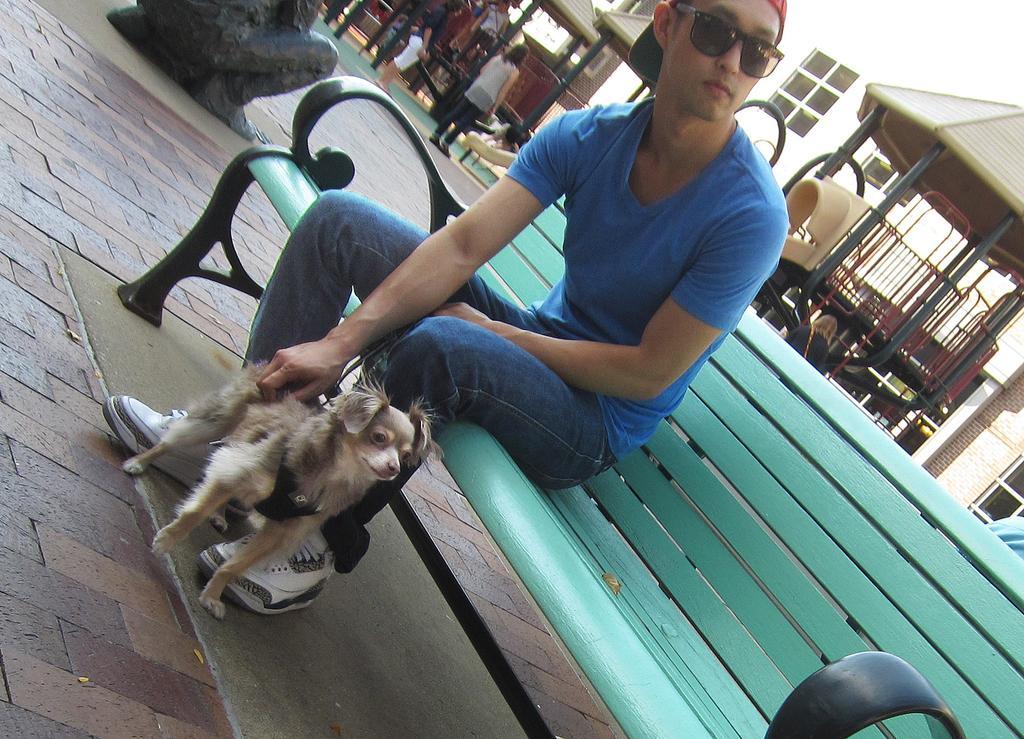Describe this image in one or two sentences. there is a green wooden bench on which a person is sitting wearing a blue t shirt, jeans, goggles and a cap. he is holding a dog which is standing on the ground. at the back there is sculpture. behind that there are slides, people are standing there. at the back there are buildings which has windows. it is street side. 